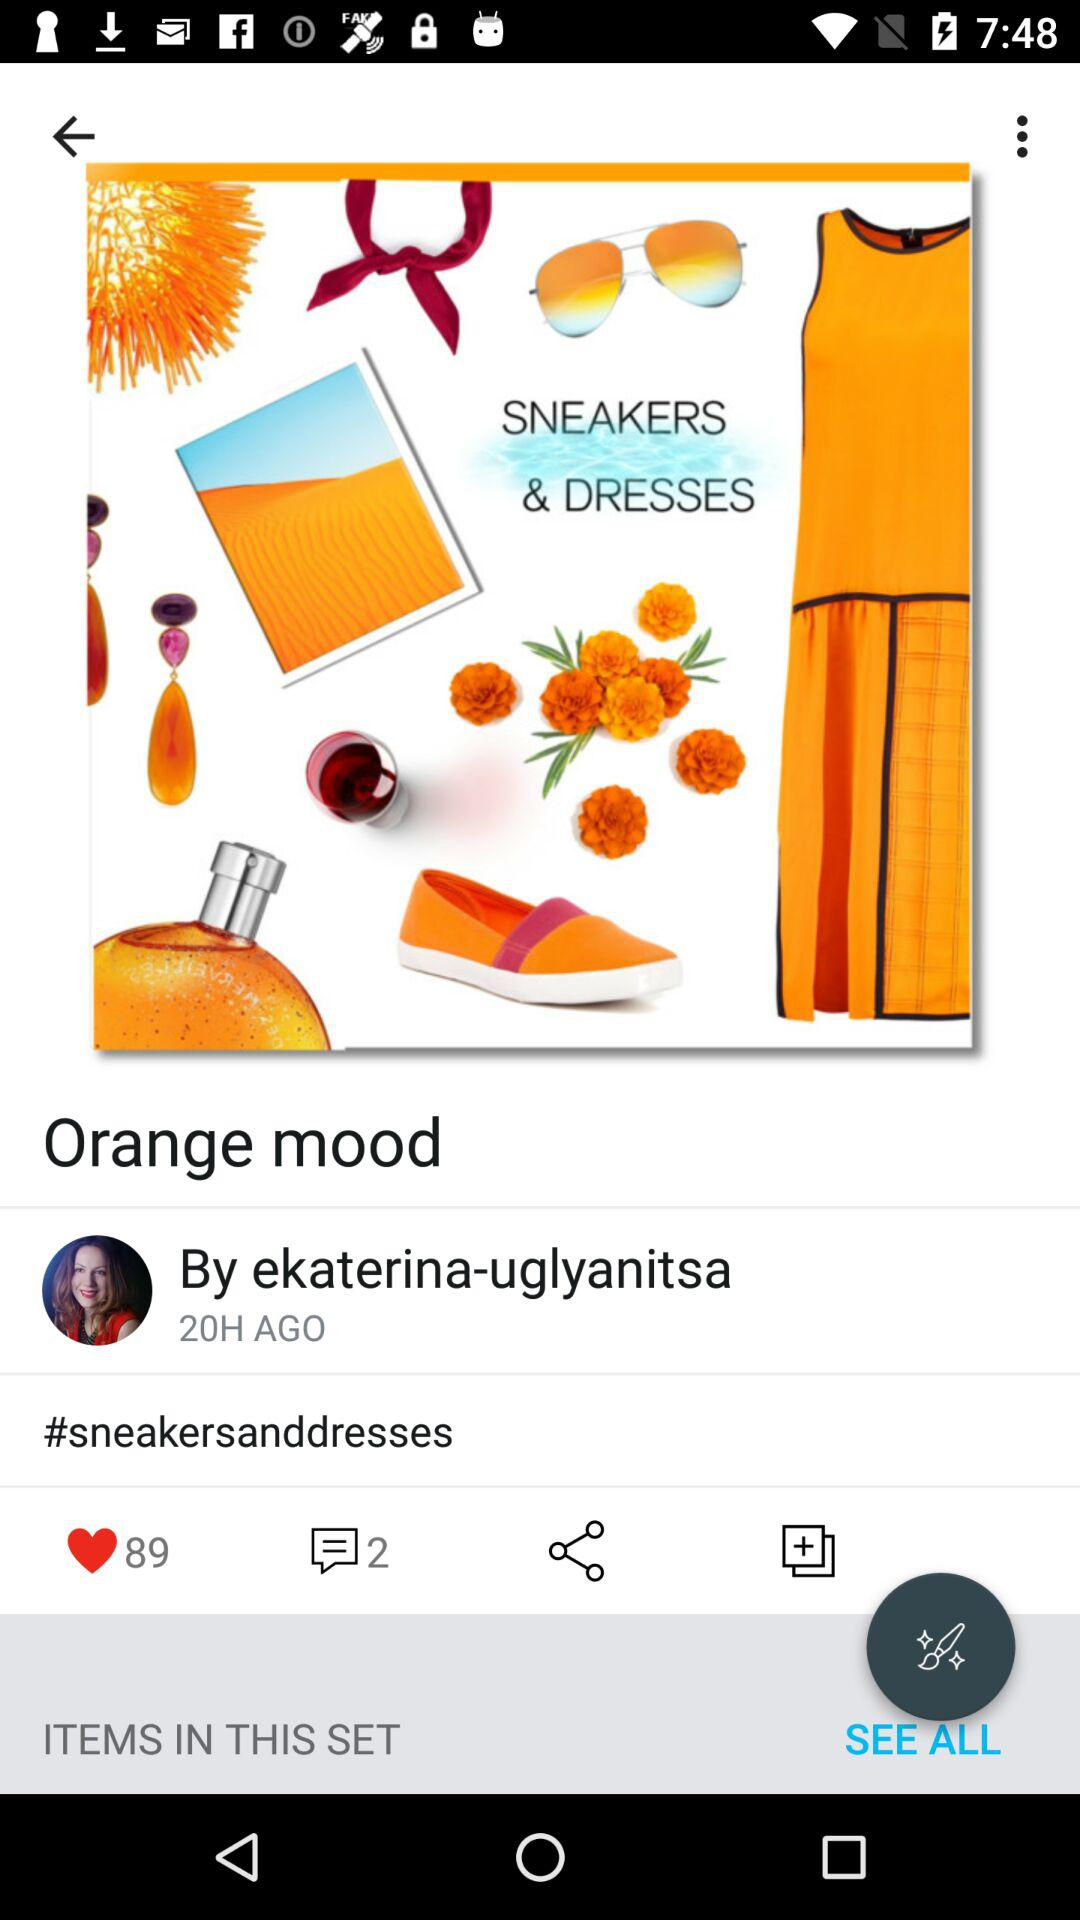How many more likes does the post have than comments?
Answer the question using a single word or phrase. 87 